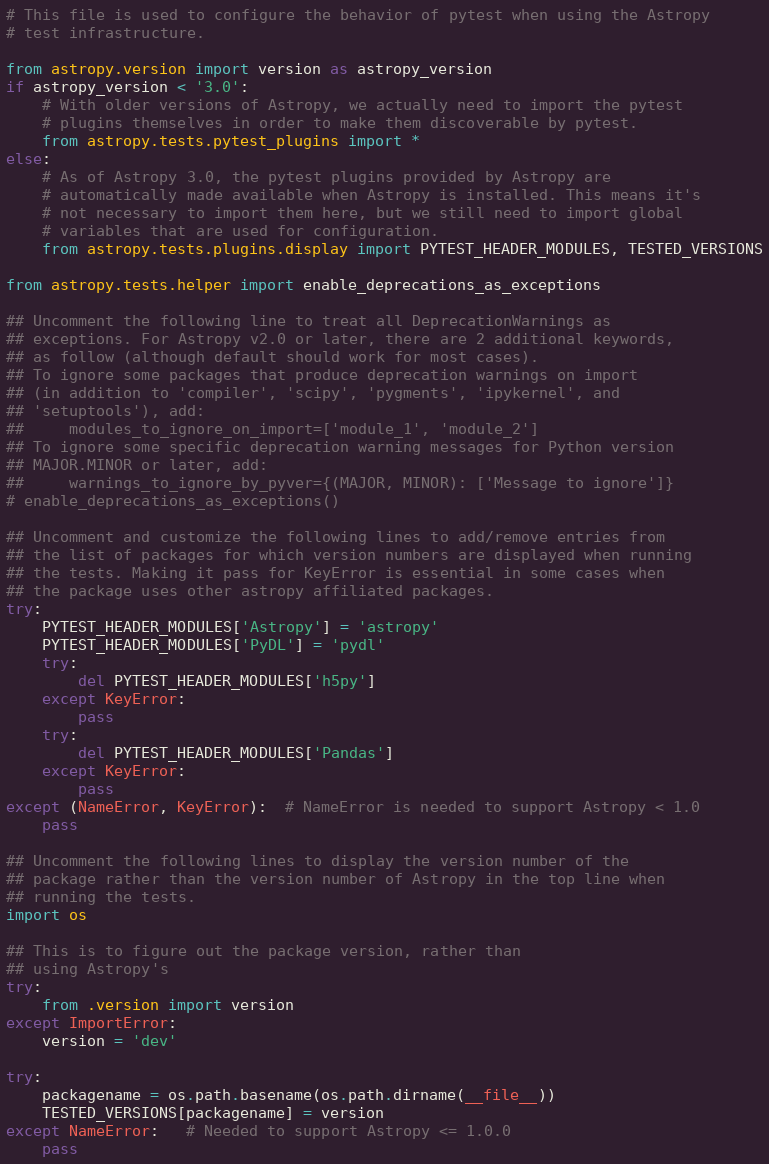Convert code to text. <code><loc_0><loc_0><loc_500><loc_500><_Python_># This file is used to configure the behavior of pytest when using the Astropy
# test infrastructure.

from astropy.version import version as astropy_version
if astropy_version < '3.0':
    # With older versions of Astropy, we actually need to import the pytest
    # plugins themselves in order to make them discoverable by pytest.
    from astropy.tests.pytest_plugins import *
else:
    # As of Astropy 3.0, the pytest plugins provided by Astropy are
    # automatically made available when Astropy is installed. This means it's
    # not necessary to import them here, but we still need to import global
    # variables that are used for configuration.
    from astropy.tests.plugins.display import PYTEST_HEADER_MODULES, TESTED_VERSIONS

from astropy.tests.helper import enable_deprecations_as_exceptions

## Uncomment the following line to treat all DeprecationWarnings as
## exceptions. For Astropy v2.0 or later, there are 2 additional keywords,
## as follow (although default should work for most cases).
## To ignore some packages that produce deprecation warnings on import
## (in addition to 'compiler', 'scipy', 'pygments', 'ipykernel', and
## 'setuptools'), add:
##     modules_to_ignore_on_import=['module_1', 'module_2']
## To ignore some specific deprecation warning messages for Python version
## MAJOR.MINOR or later, add:
##     warnings_to_ignore_by_pyver={(MAJOR, MINOR): ['Message to ignore']}
# enable_deprecations_as_exceptions()

## Uncomment and customize the following lines to add/remove entries from
## the list of packages for which version numbers are displayed when running
## the tests. Making it pass for KeyError is essential in some cases when
## the package uses other astropy affiliated packages.
try:
    PYTEST_HEADER_MODULES['Astropy'] = 'astropy'
    PYTEST_HEADER_MODULES['PyDL'] = 'pydl'
    try:
        del PYTEST_HEADER_MODULES['h5py']
    except KeyError:
        pass
    try:
        del PYTEST_HEADER_MODULES['Pandas']
    except KeyError:
        pass
except (NameError, KeyError):  # NameError is needed to support Astropy < 1.0
    pass

## Uncomment the following lines to display the version number of the
## package rather than the version number of Astropy in the top line when
## running the tests.
import os

## This is to figure out the package version, rather than
## using Astropy's
try:
    from .version import version
except ImportError:
    version = 'dev'

try:
    packagename = os.path.basename(os.path.dirname(__file__))
    TESTED_VERSIONS[packagename] = version
except NameError:   # Needed to support Astropy <= 1.0.0
    pass
</code> 